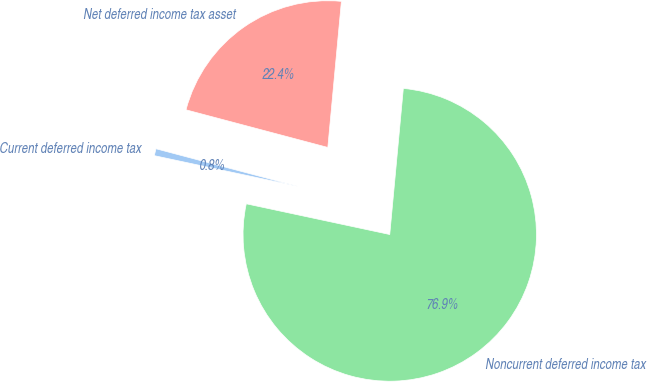<chart> <loc_0><loc_0><loc_500><loc_500><pie_chart><fcel>Current deferred income tax<fcel>Noncurrent deferred income tax<fcel>Net deferred income tax asset<nl><fcel>0.77%<fcel>76.88%<fcel>22.35%<nl></chart> 